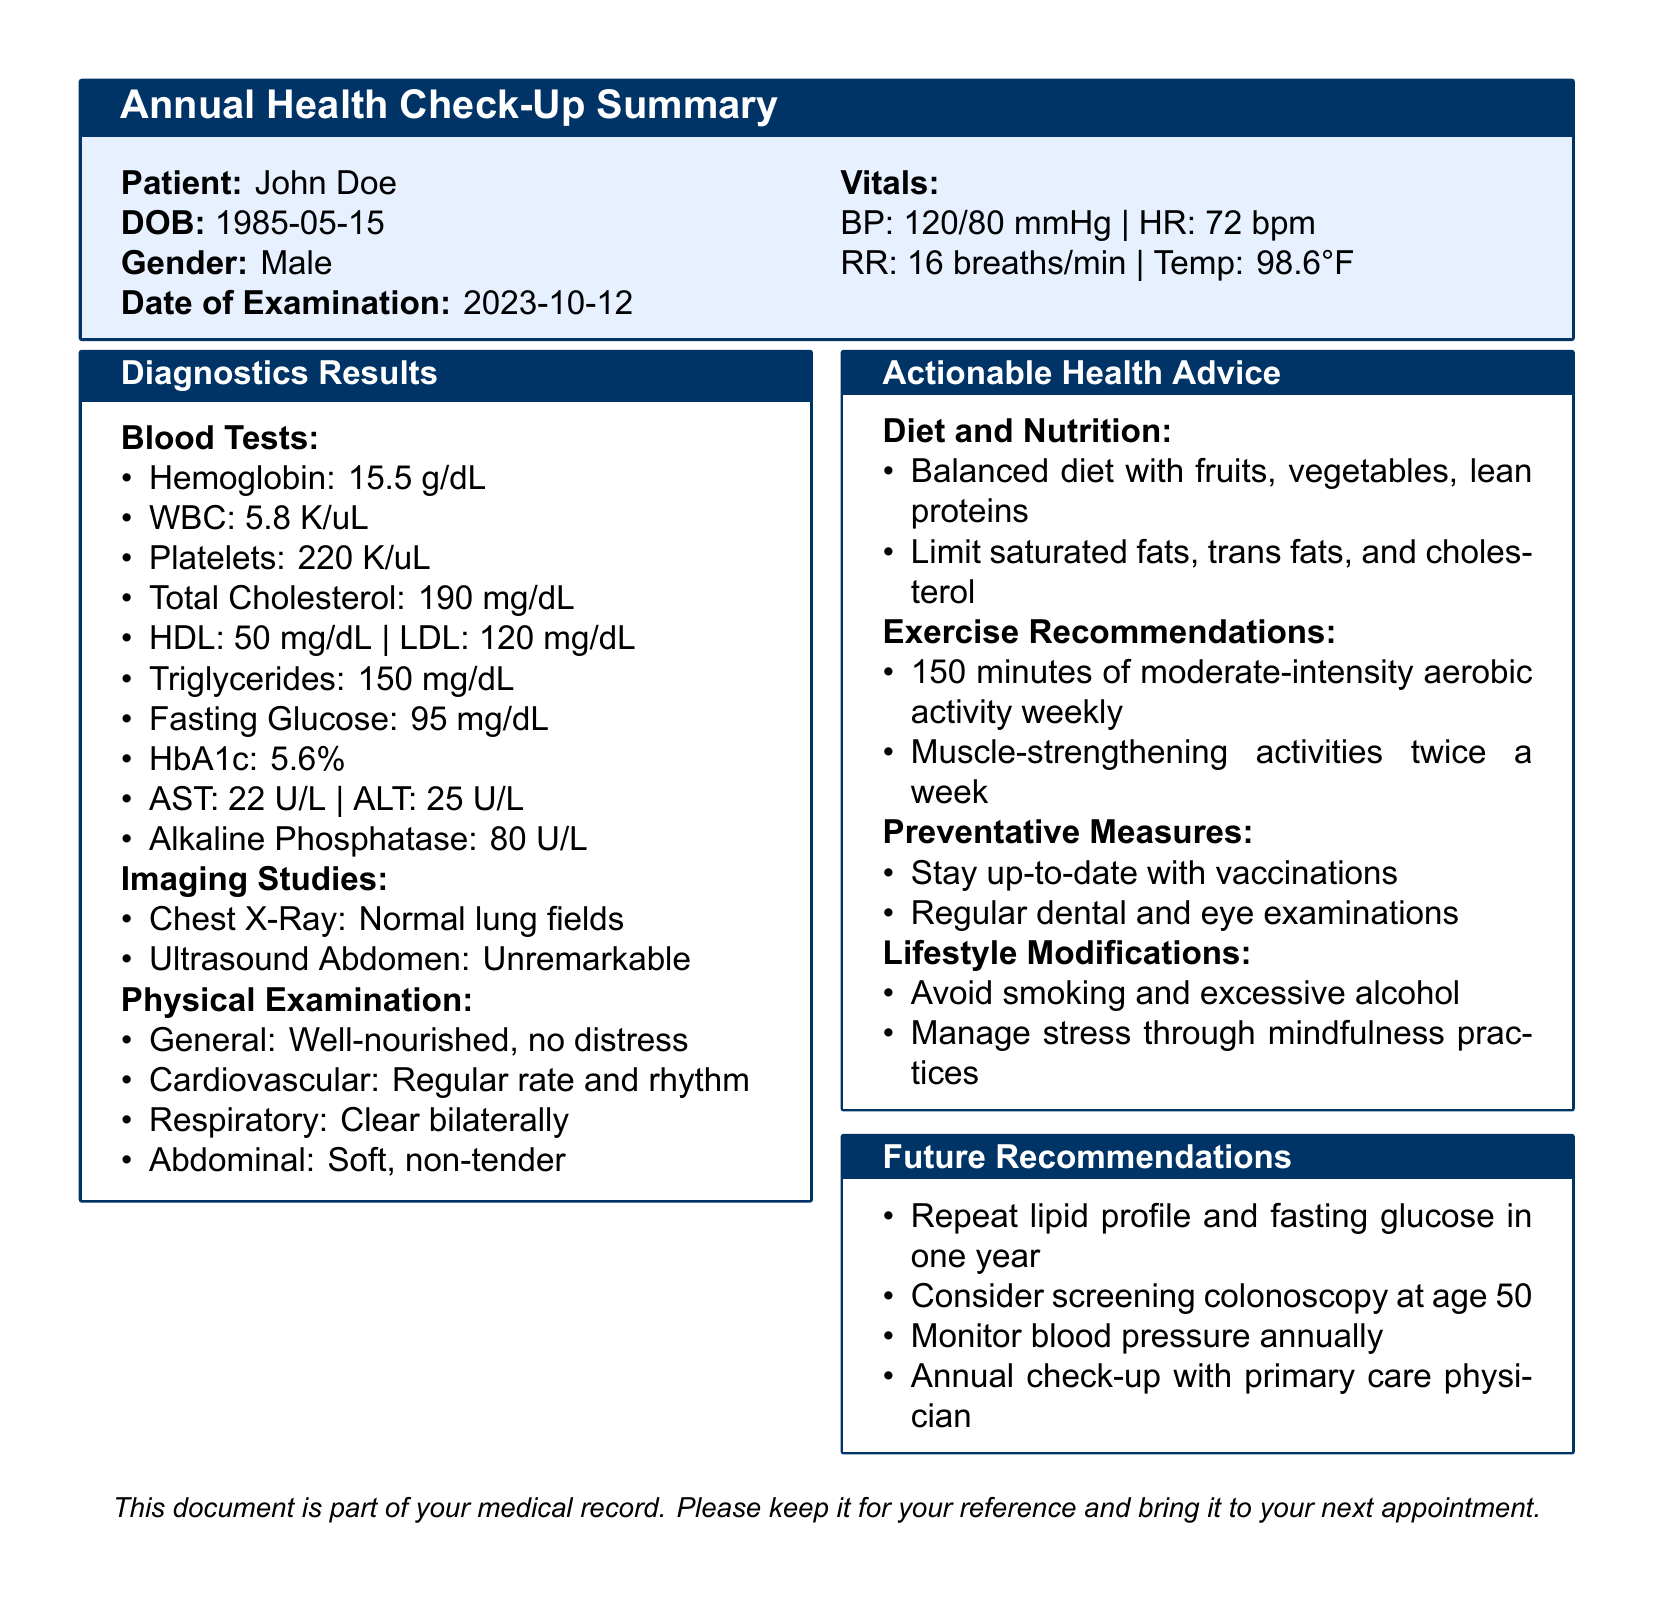What is the patient's name? The patient's name is mentioned at the beginning of the document.
Answer: John Doe What date was the examination conducted? The date of examination is specified in the document.
Answer: 2023-10-12 What is the patient's blood pressure? The vitals include blood pressure as one of the metrics measured.
Answer: 120/80 mmHg How many minutes of aerobic activity are recommended weekly? The exercise recommendations provide a specific duration for activity.
Answer: 150 minutes What is the patient's fasting glucose level? Fasting glucose level is included in the blood tests section.
Answer: 95 mg/dL What lifestyle change is advised regarding alcohol? The lifestyle modifications mention how to manage alcohol consumption.
Answer: Avoid excessive alcohol What is the cholesterol level that should be monitored annually? The future recommendations specify monitoring for a particular health metric.
Answer: Blood pressure What type of diet is recommended? The diet and nutrition section outlines what kind of diet is encouraged.
Answer: Balanced diet with fruits, vegetables, lean proteins At what age should the patient consider a screening colonoscopy? The future recommendations mention the age for a specific screening test.
Answer: 50 